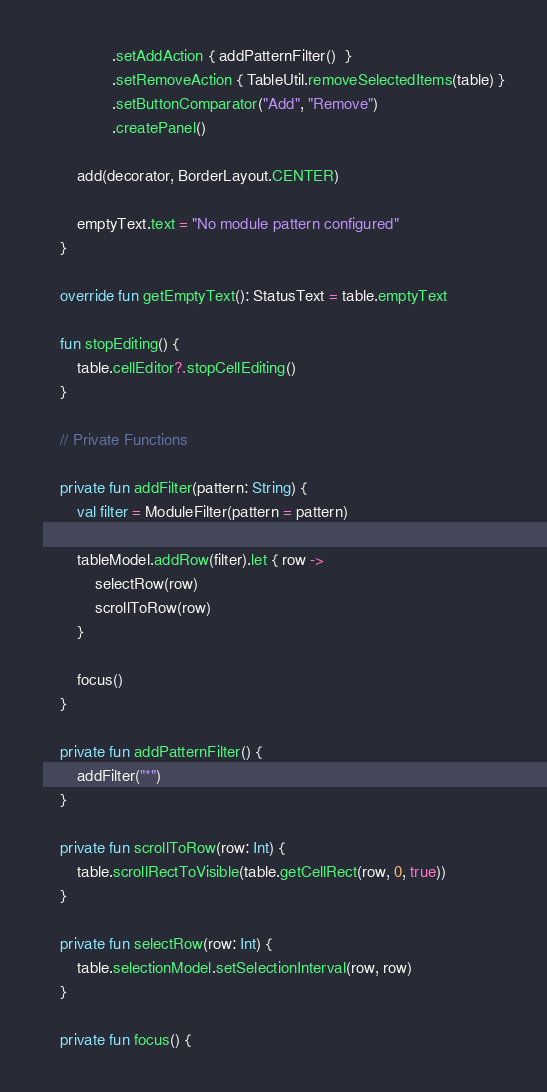<code> <loc_0><loc_0><loc_500><loc_500><_Kotlin_>                .setAddAction { addPatternFilter()  }
                .setRemoveAction { TableUtil.removeSelectedItems(table) }
                .setButtonComparator("Add", "Remove")
                .createPanel()

        add(decorator, BorderLayout.CENTER)

        emptyText.text = "No module pattern configured"
    }

    override fun getEmptyText(): StatusText = table.emptyText

    fun stopEditing() {
        table.cellEditor?.stopCellEditing()
    }

    // Private Functions

    private fun addFilter(pattern: String) {
        val filter = ModuleFilter(pattern = pattern)

        tableModel.addRow(filter).let { row ->
            selectRow(row)
            scrollToRow(row)
        }

        focus()
    }

    private fun addPatternFilter() {
        addFilter("*")
    }

    private fun scrollToRow(row: Int) {
        table.scrollRectToVisible(table.getCellRect(row, 0, true))
    }

    private fun selectRow(row: Int) {
        table.selectionModel.setSelectionInterval(row, row)
    }

    private fun focus() {</code> 